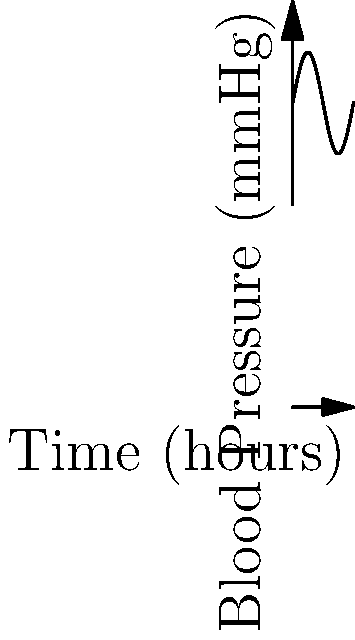A medical researcher is studying blood pressure fluctuations over a 24-hour period. The blood pressure (in mmHg) can be modeled by the function $P(t) = 120 + 20\sin(\frac{2\pi t}{24})$, where $t$ is the time in hours. At what time during the first 12 hours does the blood pressure reach its maximum value? To find the maximum blood pressure, we need to follow these steps:

1) The sine function reaches its maximum value when its argument is $\frac{\pi}{2}$ (or 90 degrees).

2) So, we need to solve the equation:

   $\frac{2\pi t}{24} = \frac{\pi}{2}$

3) Multiply both sides by 24:
   
   $2\pi t = 12\pi$

4) Divide both sides by $2\pi$:

   $t = 6$

5) This means the blood pressure reaches its maximum 6 hours into the cycle.

6) To verify, we can calculate the blood pressure at this time:

   $P(6) = 120 + 20\sin(\frac{2\pi \cdot 6}{24}) = 120 + 20\sin(\frac{\pi}{2}) = 120 + 20 = 140$ mmHg

This is indeed the maximum value, as the amplitude of the sine wave is 20 and it's added to the base value of 120.
Answer: 6 hours 